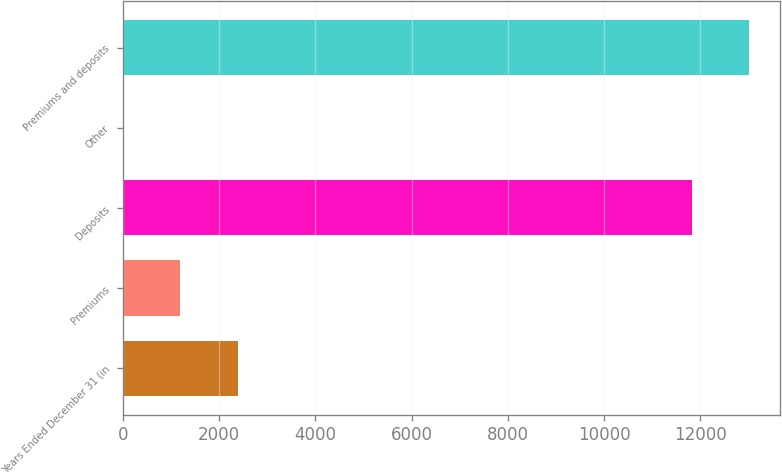<chart> <loc_0><loc_0><loc_500><loc_500><bar_chart><fcel>Years Ended December 31 (in<fcel>Premiums<fcel>Deposits<fcel>Other<fcel>Premiums and deposits<nl><fcel>2384.4<fcel>1194.2<fcel>11819<fcel>4<fcel>13009.2<nl></chart> 